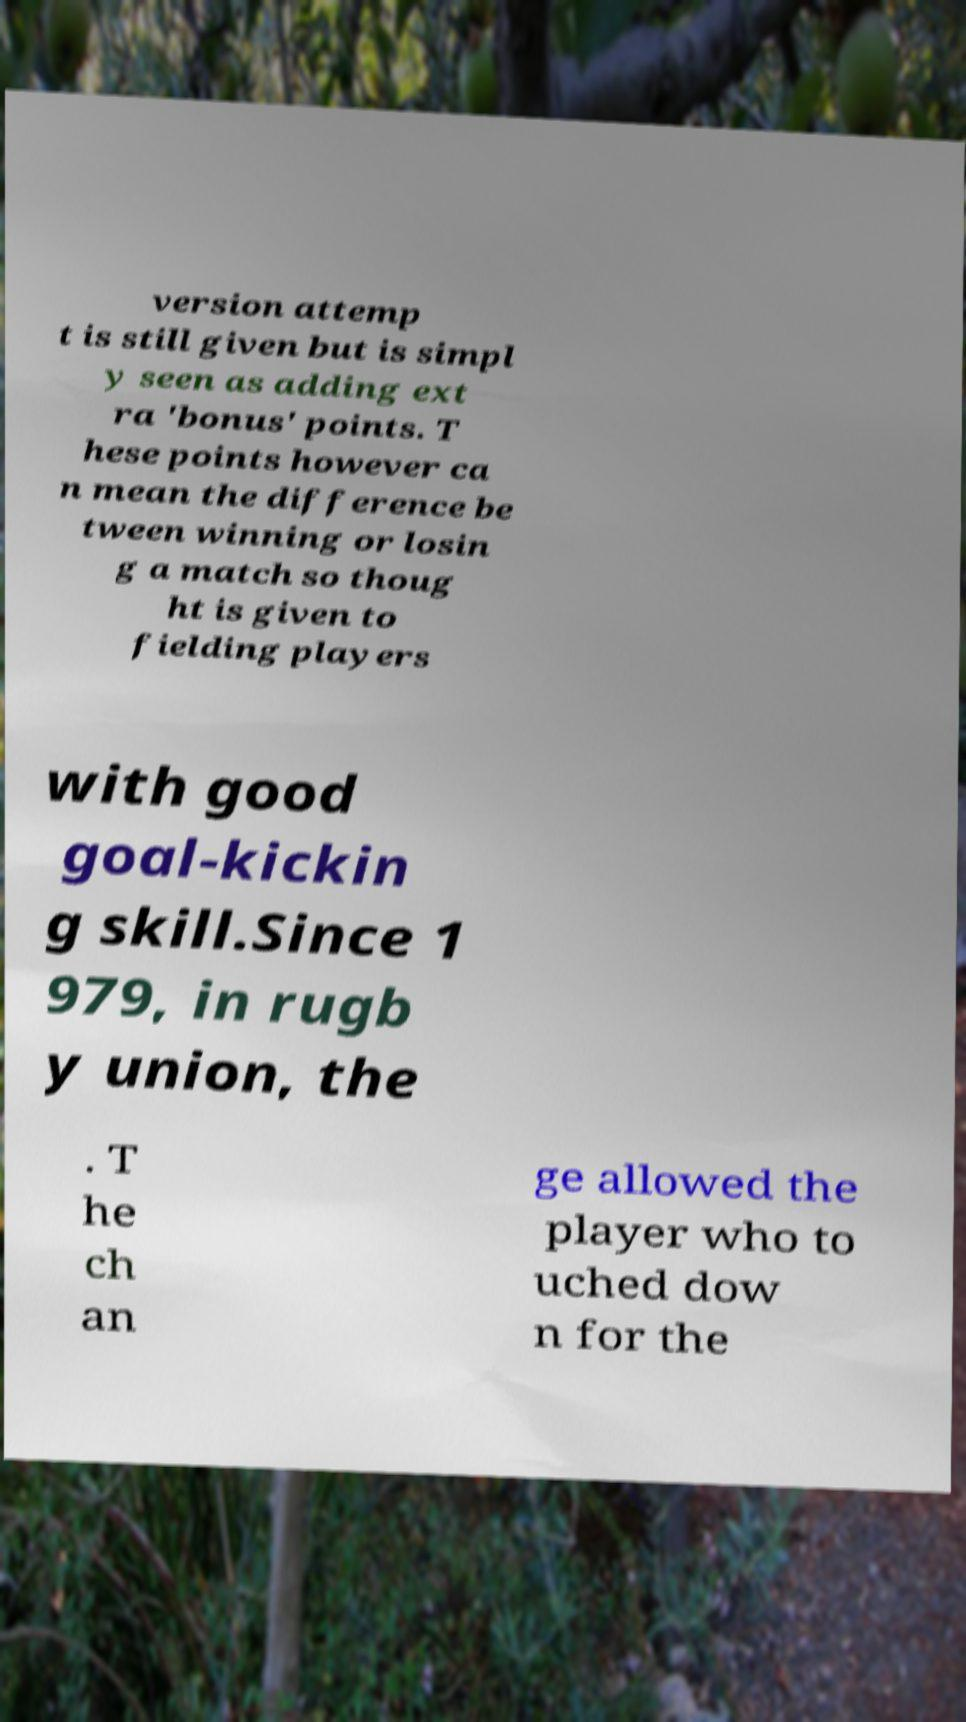Please identify and transcribe the text found in this image. version attemp t is still given but is simpl y seen as adding ext ra 'bonus' points. T hese points however ca n mean the difference be tween winning or losin g a match so thoug ht is given to fielding players with good goal-kickin g skill.Since 1 979, in rugb y union, the . T he ch an ge allowed the player who to uched dow n for the 